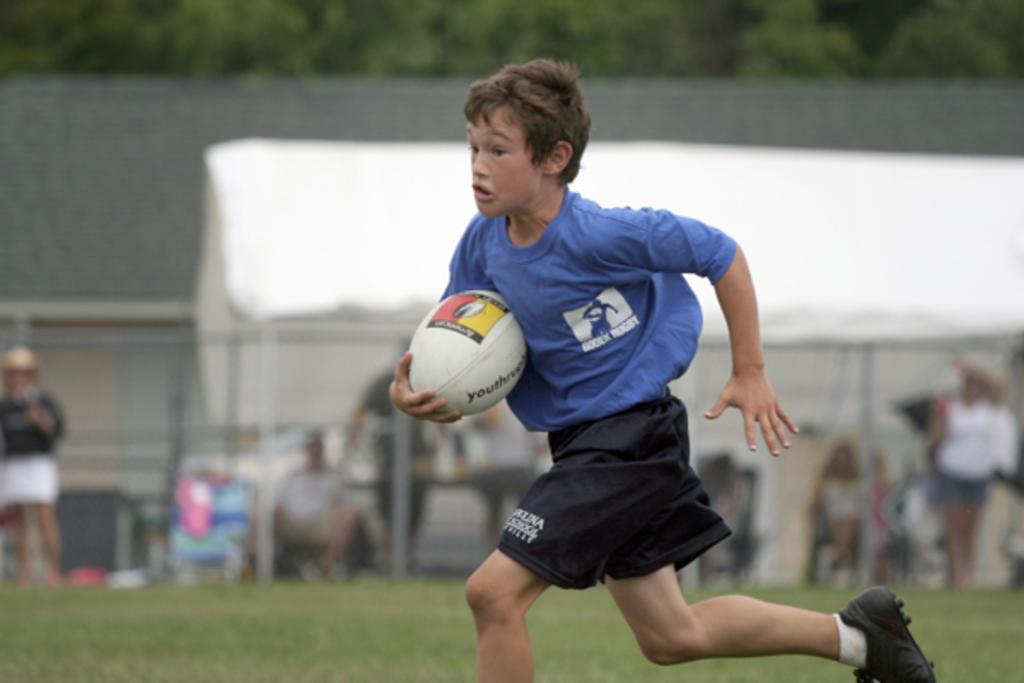Please provide a concise description of this image. Here we can see a boy holding a ball in his hand and running on a foot ball ground. 